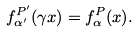<formula> <loc_0><loc_0><loc_500><loc_500>f _ { \alpha ^ { \prime } } ^ { P ^ { \prime } } ( \gamma x ) = f _ { \alpha } ^ { P } ( x ) .</formula> 